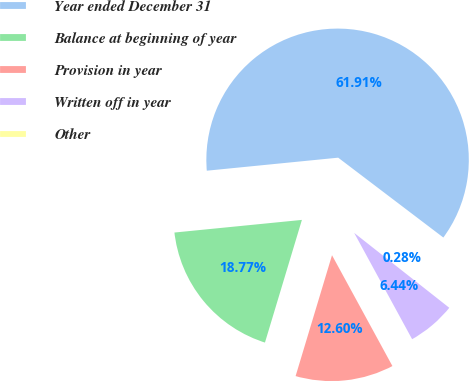<chart> <loc_0><loc_0><loc_500><loc_500><pie_chart><fcel>Year ended December 31<fcel>Balance at beginning of year<fcel>Provision in year<fcel>Written off in year<fcel>Other<nl><fcel>61.91%<fcel>18.77%<fcel>12.6%<fcel>6.44%<fcel>0.28%<nl></chart> 